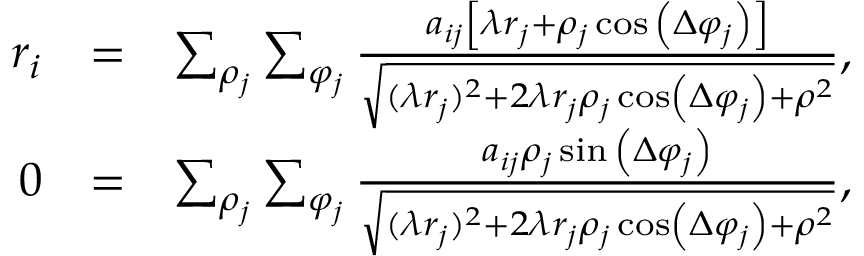Convert formula to latex. <formula><loc_0><loc_0><loc_500><loc_500>\begin{array} { r l r } { r _ { i } } & { = } & { \sum _ { \rho _ { j } } \sum _ { \varphi _ { j } } \frac { a _ { i j } \left [ \lambda r _ { j } + \rho _ { j } \cos { \left ( \Delta \varphi _ { j } \right ) } \right ] } { \sqrt { ( \lambda r _ { j } ) ^ { 2 } + 2 \lambda r _ { j } \rho _ { j } \cos \left ( \Delta \varphi _ { j } \right ) + \rho ^ { 2 } } } , } \\ { 0 } & { = } & { \sum _ { \rho _ { j } } \sum _ { \varphi _ { j } } \frac { a _ { i j } \rho _ { j } \sin { \left ( \Delta \varphi _ { j } \right ) } } { \sqrt { ( \lambda r _ { j } ) ^ { 2 } + 2 \lambda r _ { j } \rho _ { j } \cos \left ( \Delta \varphi _ { j } \right ) + \rho ^ { 2 } } } , } \end{array}</formula> 